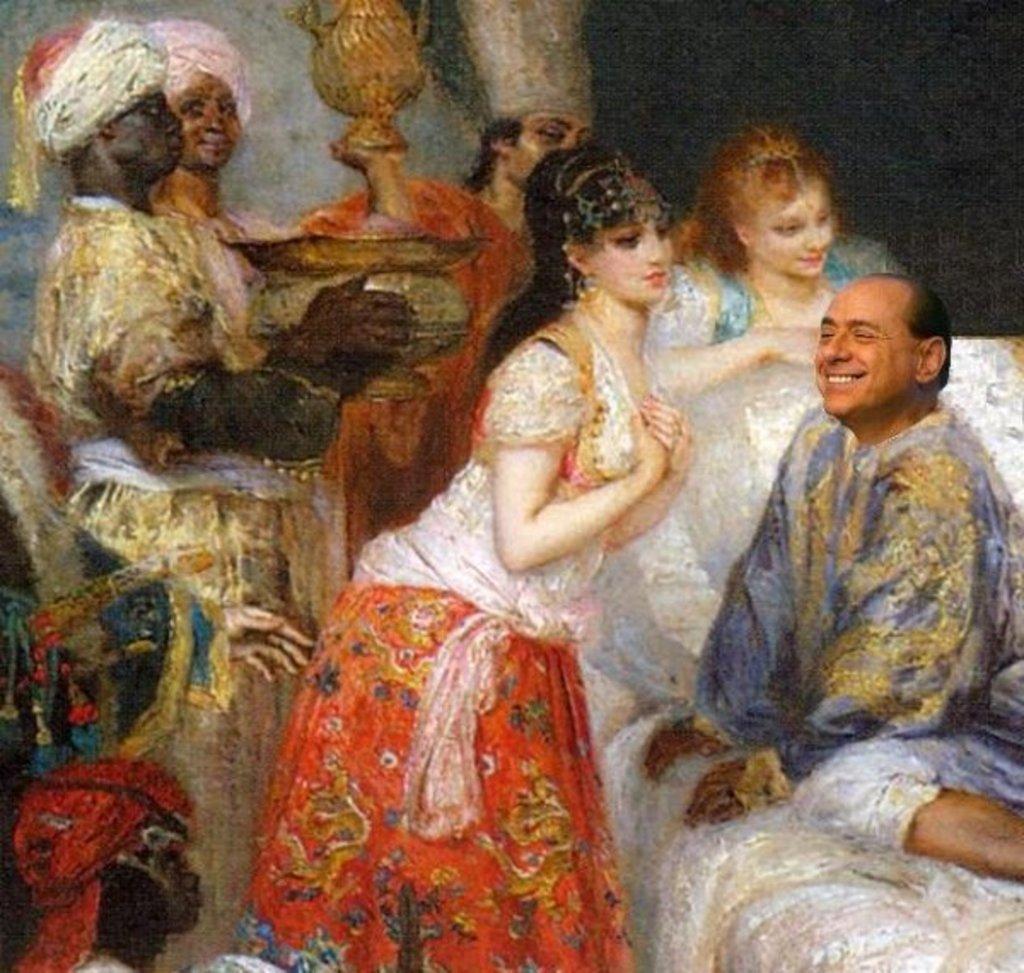Can you describe this image briefly? This image consists of a painting. In this image there are two women and there are four men. Two men are holding objects in their hands. On the right side of the image we can see the face of a person. 